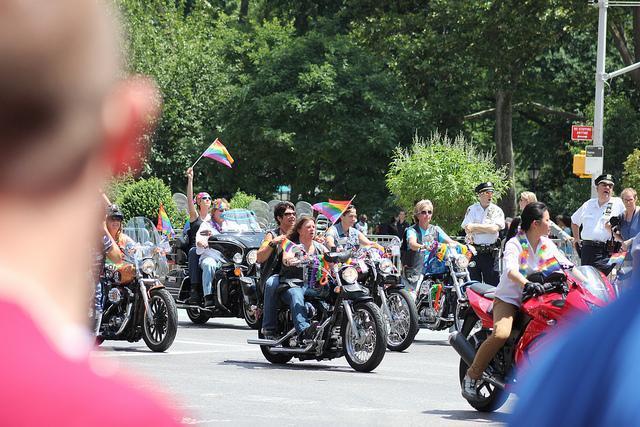How many people are there?
Give a very brief answer. 7. How many motorcycles are there?
Give a very brief answer. 6. 